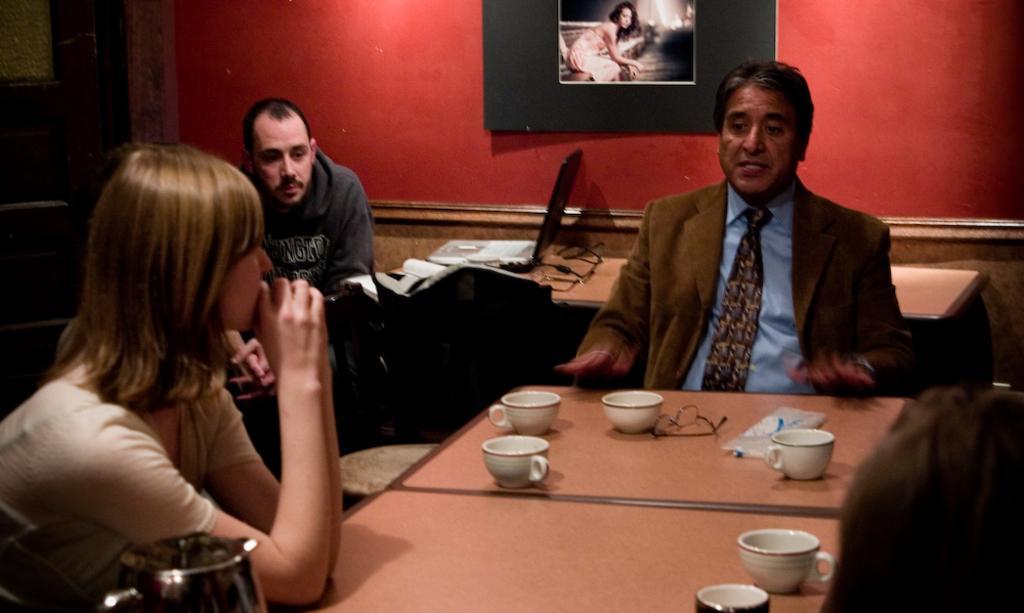Please provide a concise description of this image. In this image we have group of people among them two men are sitting on a chair and a woman is sitting on a chair in front of the table. On the table we have a few cups and a spectacle and few other objects on it. Behind this man we have a red wall with a wall photo on it. 